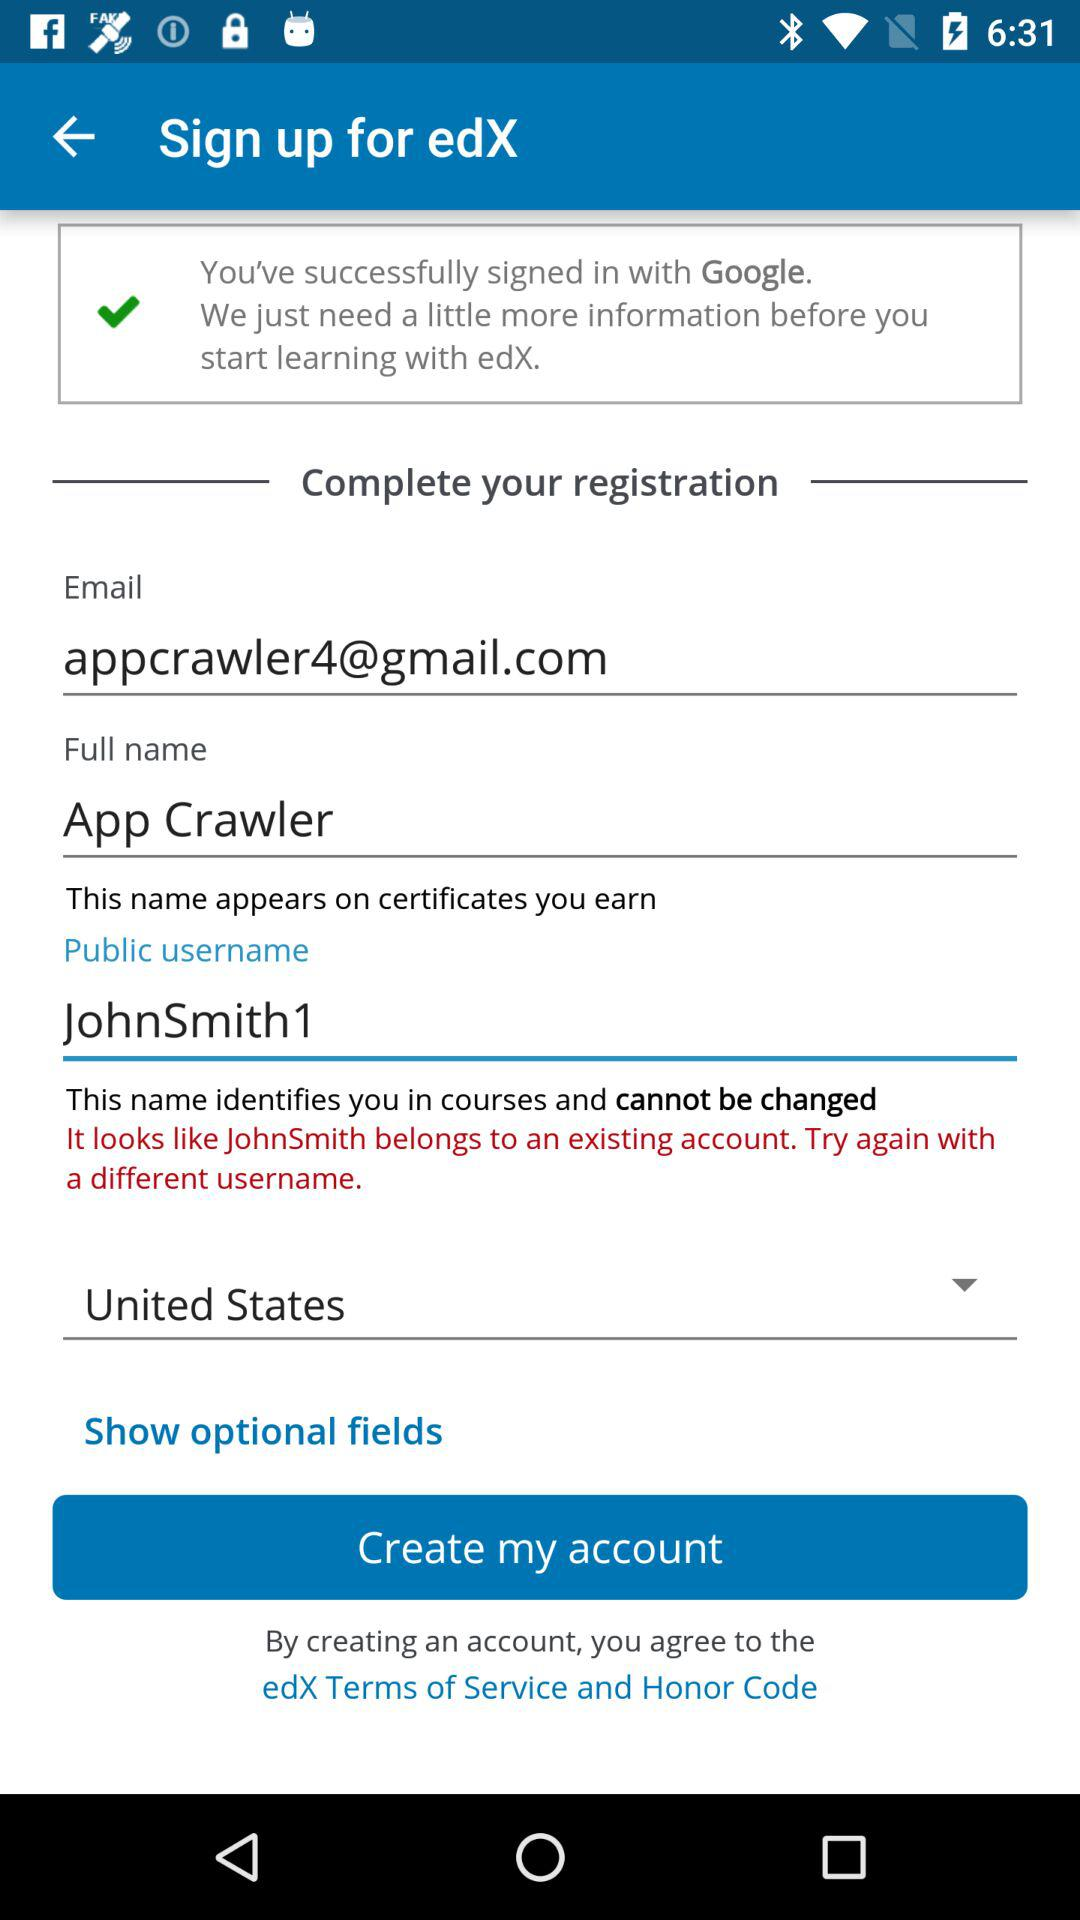What is the email address? The email address is appcrawler4@gmail.com. 